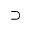<formula> <loc_0><loc_0><loc_500><loc_500>\supset</formula> 